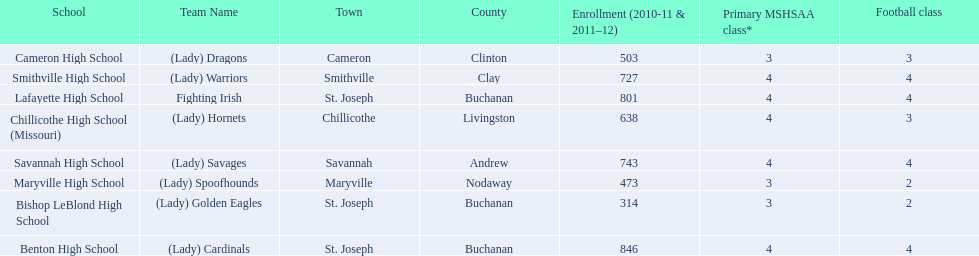What schools are located in st. joseph? Benton High School, Bishop LeBlond High School, Lafayette High School. Which st. joseph schools have more then 800 enrollment  for 2010-11 7 2011-12? Benton High School, Lafayette High School. What is the name of the st. joseph school with 800 or more enrollment's team names is a not a (lady)? Lafayette High School. 